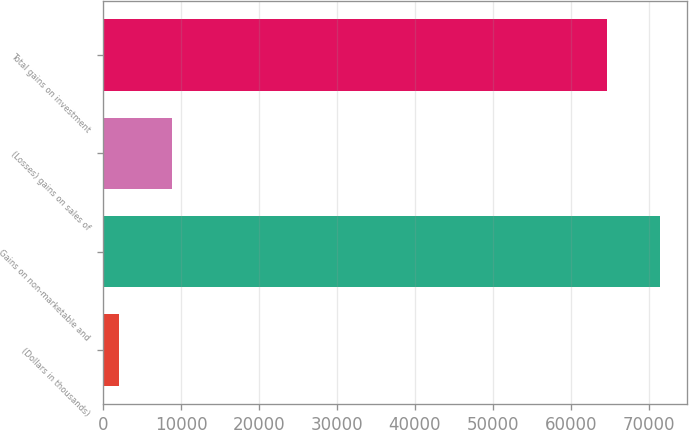Convert chart to OTSL. <chart><loc_0><loc_0><loc_500><loc_500><bar_chart><fcel>(Dollars in thousands)<fcel>Gains on non-marketable and<fcel>(Losses) gains on sales of<fcel>Total gains on investment<nl><fcel>2017<fcel>71380.5<fcel>8794.5<fcel>64603<nl></chart> 